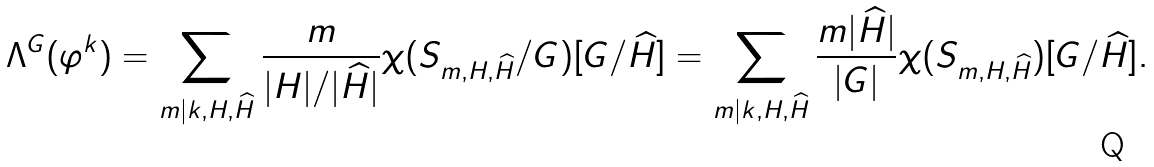Convert formula to latex. <formula><loc_0><loc_0><loc_500><loc_500>\Lambda ^ { G } ( \varphi ^ { k } ) = \sum _ { m | k , H , { \widehat { H } } } \frac { m } { | H | / | { \widehat { H } } | } \chi ( S _ { m , H , { \widehat { H } } } / G ) [ G / { \widehat { H } } ] = \sum _ { m | k , H , { \widehat { H } } } \frac { m | { \widehat { H } } | } { | G | } \chi ( S _ { m , H , { \widehat { H } } } ) [ G / { \widehat { H } } ] .</formula> 